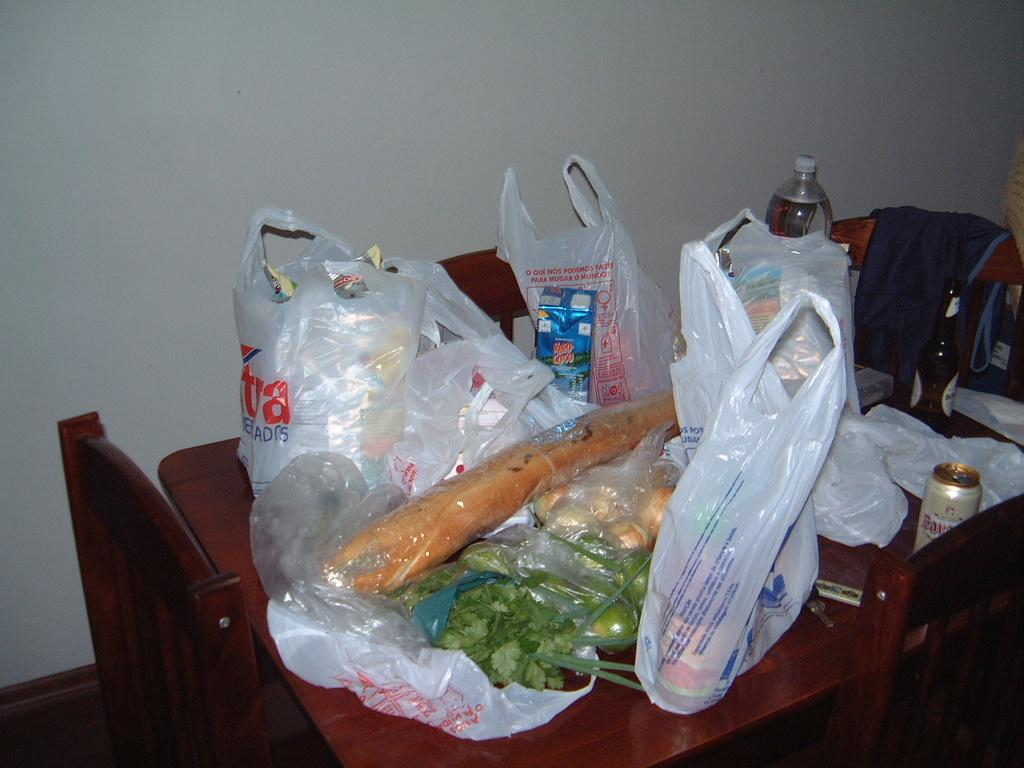What type of covering is on the table in the image? There are plastic covers on the table. What is the primary object on the table? There is a bottle on the table. What type of food items can be seen on the table? There are vegetables on the table. What other small objects are on the table? A: There are keys on the table. What type of container is on the table? There is a tin on the table. How many chairs are around the table? There are chairs around the table. What is on one of the chairs? There is a jacket on one of the chairs. What type of grass can be seen growing on the table in the image? There is no grass growing on the table in the image. What pet is sitting on one of the chairs in the image? There is no pet present in the image; only a jacket is on one of the chairs. 